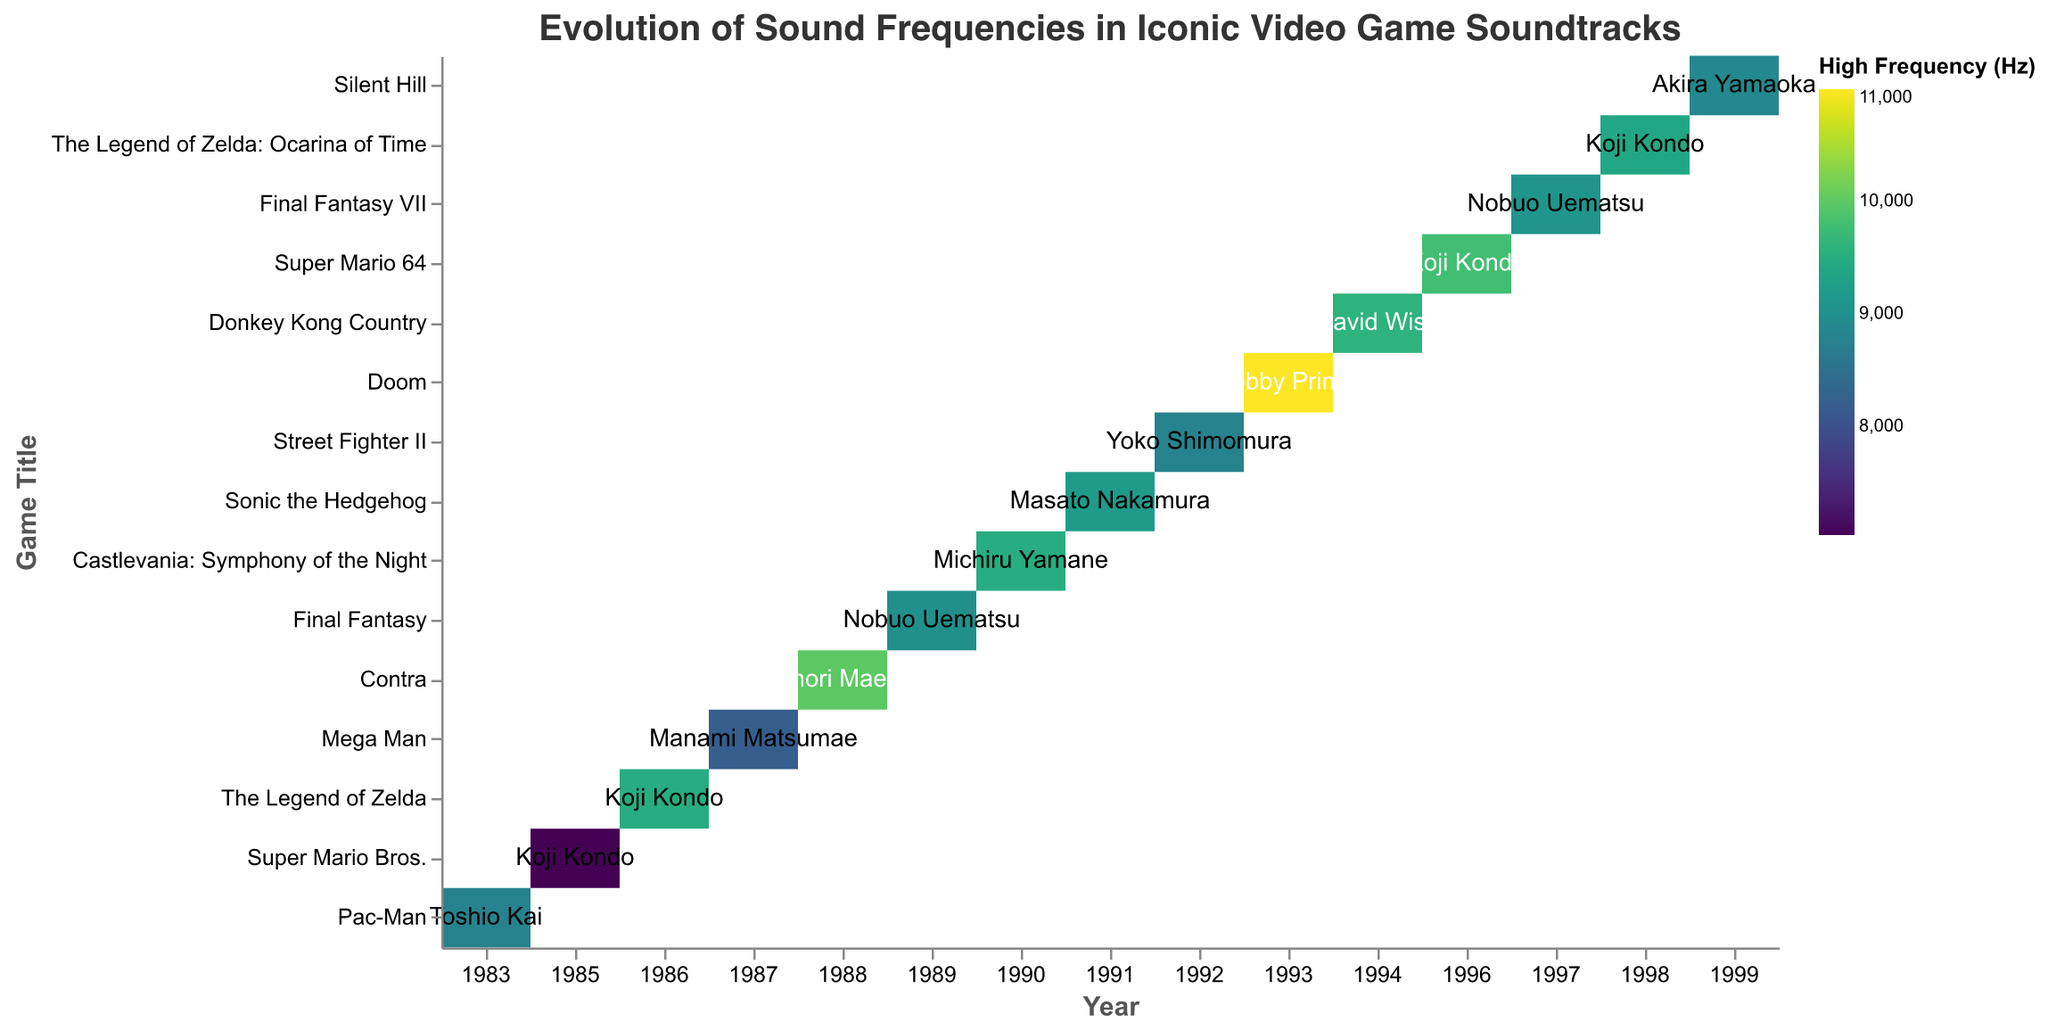What is the title of the figure? The title of the figure is at the top and specifies what the data represents.
Answer: Evolution of Sound Frequencies in Iconic Video Game Soundtracks Which game has the highest high frequency in its soundtrack? In the heatmap, identify the game with the darkest color indicating the highest high frequency value.
Answer: Doom How many games composed by Koji Kondo are represented in the heatmap? Count the number of game titles labeled with Koji Kondo as the composer.
Answer: 4 What is the low frequency value for Super Mario Bros. in 1985? Locate the row for Super Mario Bros. in 1985 and look at the low frequency field.
Answer: 44 Hz Which game from the 80s has the lowest mid frequency and what is that value? Identify and compare the mid frequency values for all games from the 80s to find the lowest one.
Answer: Super Mario Bros. with 294 Hz Is there any game where the high frequency is exactly 9500 Hz? If so, which one? Check the high frequency values in the heatmap for the value of 9500 Hz.
Answer: The Legend of Zelda and Castlevania: Symphony of the Night What is the difference in high frequency between Sonic the Hedgehog and Pac-Man? Subtract the high frequency of Pac-Man from Sonic the Hedgehog.
Answer: 400 Hz Which game has the lowest low frequency value and what is that value? Identify and compare the low frequency values for all games to find the lowest one.
Answer: Super Mario Bros. with 44 Hz How does the high frequency of Final Fantasy VII compare to Silent Hill? Compare the high frequency values of Final Fantasy VII and Silent Hill.
Answer: Final Fantasy VII has a slightly higher frequency (9100 Hz) compared to Silent Hill (8900 Hz) What are the mid frequency values for the games composed by Nobuo Uematsu? Extract the mid frequency values for games where Nobuo Uematsu is the composer.
Answer: 350 Hz and 370 Hz Which composer has the highest mid frequency value represented in the heatmap and which game is it for? Locate and identify the highest mid frequency value and match it to its corresponding composer and game.
Answer: Bobby Prince for Doom with 500 Hz 